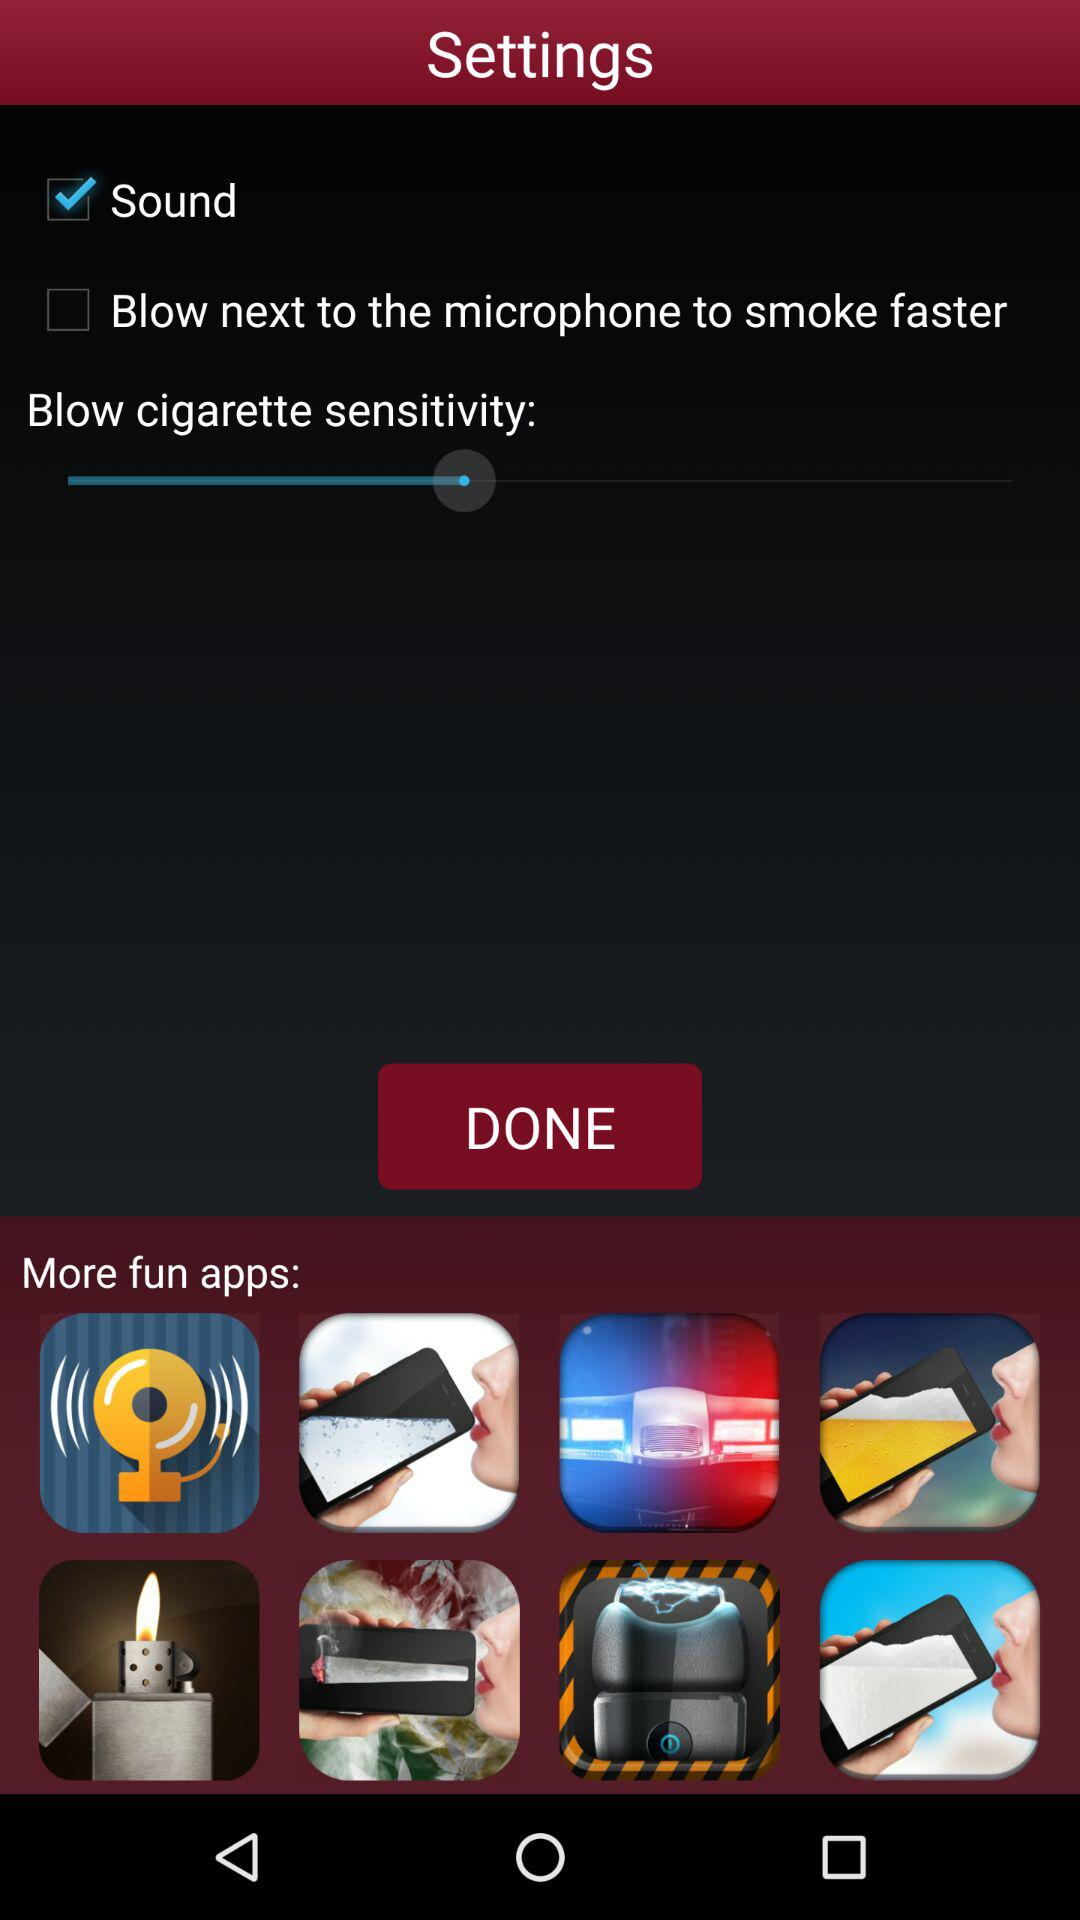Which settings are unchecked? The unchecked setting is "Blow next to the microphone to smoke faster". 